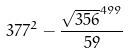Convert formula to latex. <formula><loc_0><loc_0><loc_500><loc_500>3 7 7 ^ { 2 } - \frac { \sqrt { 3 5 6 } ^ { 4 9 9 } } { 5 9 }</formula> 